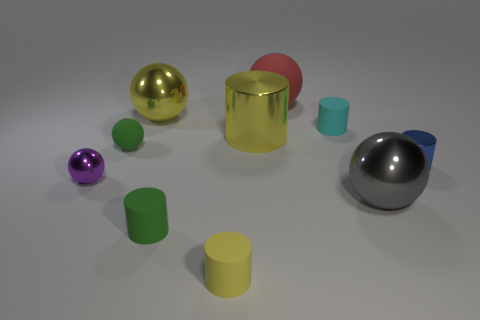Subtract 1 cylinders. How many cylinders are left? 4 Subtract all yellow balls. How many balls are left? 4 Subtract all tiny blue cylinders. How many cylinders are left? 4 Subtract all purple cylinders. Subtract all blue blocks. How many cylinders are left? 5 Add 9 small blue metallic objects. How many small blue metallic objects are left? 10 Add 3 small yellow objects. How many small yellow objects exist? 4 Subtract 0 red cylinders. How many objects are left? 10 Subtract all purple objects. Subtract all small matte cylinders. How many objects are left? 6 